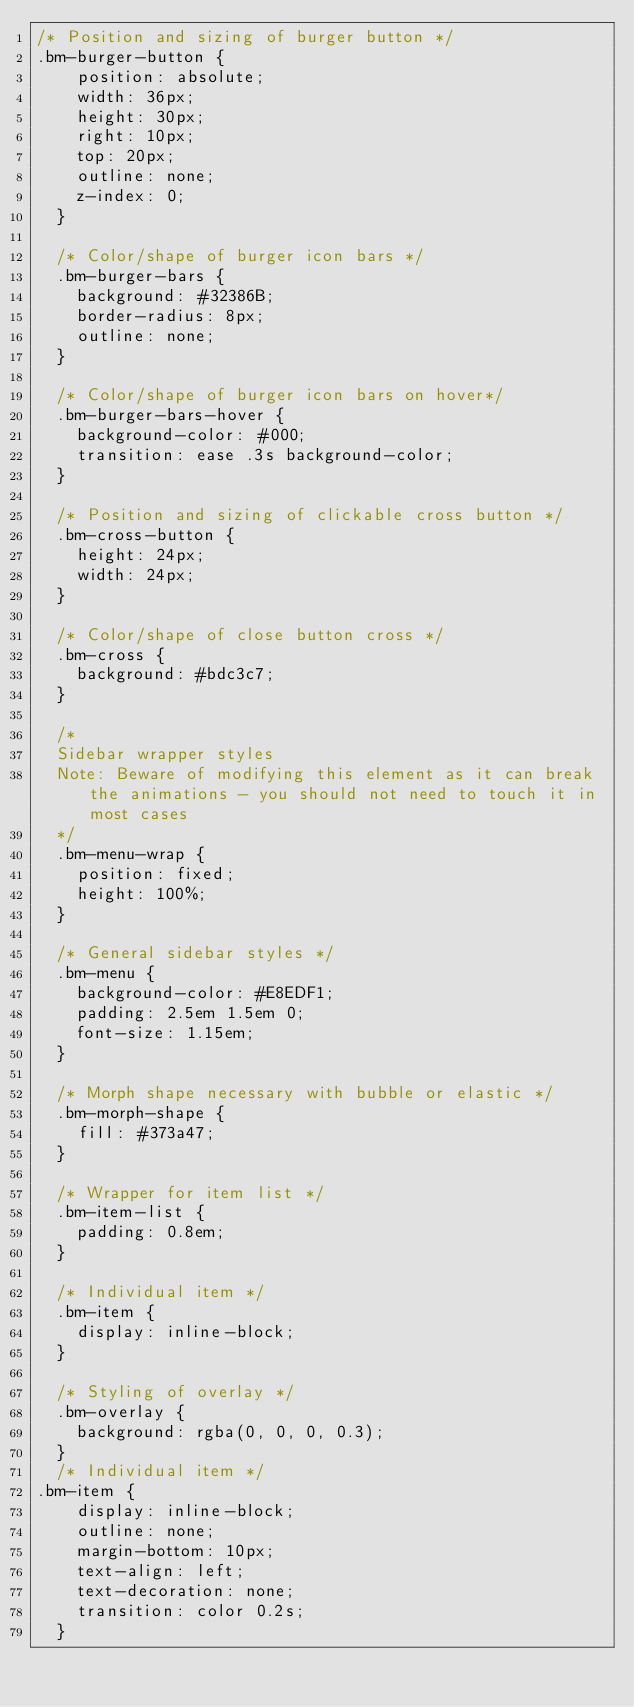Convert code to text. <code><loc_0><loc_0><loc_500><loc_500><_CSS_>/* Position and sizing of burger button */
.bm-burger-button {
    position: absolute;
    width: 36px;
    height: 30px;
    right: 10px;
    top: 20px;
    outline: none;
    z-index: 0;
  }
  
  /* Color/shape of burger icon bars */
  .bm-burger-bars {
    background: #32386B;
    border-radius: 8px;
    outline: none;
  }
  
  /* Color/shape of burger icon bars on hover*/
  .bm-burger-bars-hover {
    background-color: #000;
    transition: ease .3s background-color;
  }
  
  /* Position and sizing of clickable cross button */
  .bm-cross-button {
    height: 24px;
    width: 24px;
  }
  
  /* Color/shape of close button cross */
  .bm-cross {
    background: #bdc3c7;
  }
  
  /*
  Sidebar wrapper styles
  Note: Beware of modifying this element as it can break the animations - you should not need to touch it in most cases
  */
  .bm-menu-wrap {
    position: fixed;
    height: 100%;
  }
  
  /* General sidebar styles */
  .bm-menu {
    background-color: #E8EDF1;
    padding: 2.5em 1.5em 0;
    font-size: 1.15em;
  }
  
  /* Morph shape necessary with bubble or elastic */
  .bm-morph-shape {
    fill: #373a47;
  }
  
  /* Wrapper for item list */
  .bm-item-list {
    padding: 0.8em;
  }
  
  /* Individual item */
  .bm-item {
    display: inline-block;
  }
  
  /* Styling of overlay */
  .bm-overlay {
    background: rgba(0, 0, 0, 0.3);
  }
  /* Individual item */
.bm-item {
    display: inline-block;
    outline: none;
    margin-bottom: 10px;
    text-align: left;
    text-decoration: none;
    transition: color 0.2s;
  }</code> 